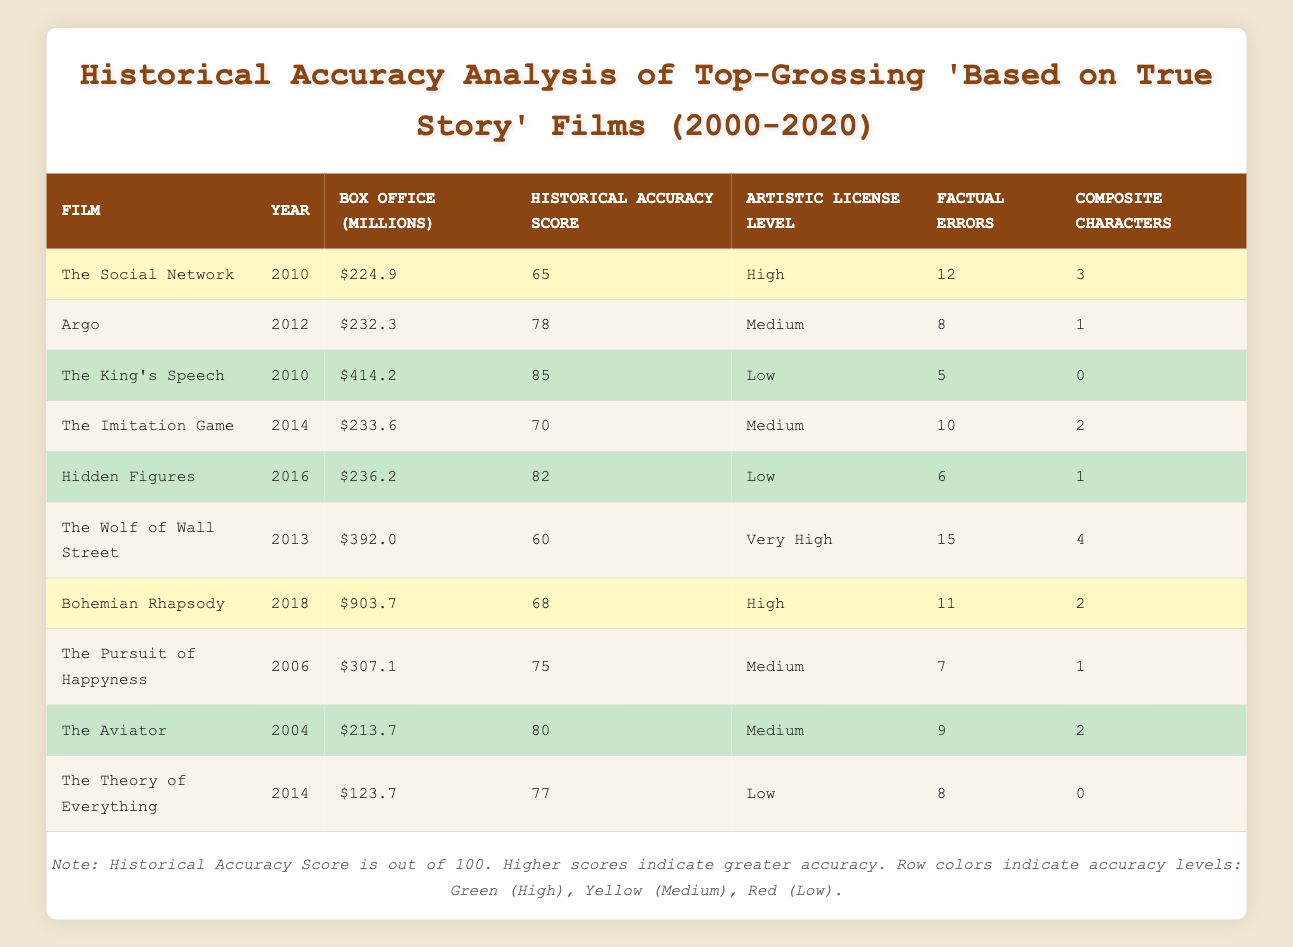What is the film with the highest box office gross? The film with the highest box office gross is "Bohemian Rhapsody," which earned $903.7 million.
Answer: Bohemian Rhapsody How many films in the table have a historical accuracy score above 80? There are 4 films with a historical accuracy score above 80: "The King's Speech" (85), "Hidden Figures" (82), "The Aviator" (80), and "Argo" (78).
Answer: 4 What is the average historical accuracy score for films with high artistic license levels? The scores for films with high or very high artistic license levels are 65 (The Social Network), 60 (The Wolf of Wall Street), and 68 (Bohemian Rhapsody). The average is (65 + 60 + 68) / 3 = 64.33.
Answer: 64.33 Did any film released in the 2000s have a lower historical accuracy score than "The Pursuit of Happyness"? "The Pursuit of Happyness" has a historical accuracy score of 75. The only film from the 2000s with a lower score is "The Social Network," which scored 65. Therefore, yes, there is one.
Answer: Yes Which film has the most factual errors, and how many? "The Wolf of Wall Street" has the most factual errors with 15.
Answer: The Wolf of Wall Street, 15 What is the difference between the historical accuracy scores of "The King's Speech" and "The Imitation Game"? "The King's Speech" has a score of 85, and "The Imitation Game" has a score of 70. The difference is 85 - 70 = 15.
Answer: 15 Identify a film that has no composite characters and its historical accuracy score. "The King's Speech" has no composite characters and a historical accuracy score of 85.
Answer: The King's Speech, 85 How many films were directed by Martin Scorsese, and what are their historical accuracy scores? Martin Scorsese directed two films: "The Aviator" (80) and "The Wolf of Wall Street" (60). So, there are two films directed by him.
Answer: 2, The Aviator 80, The Wolf of Wall Street 60 